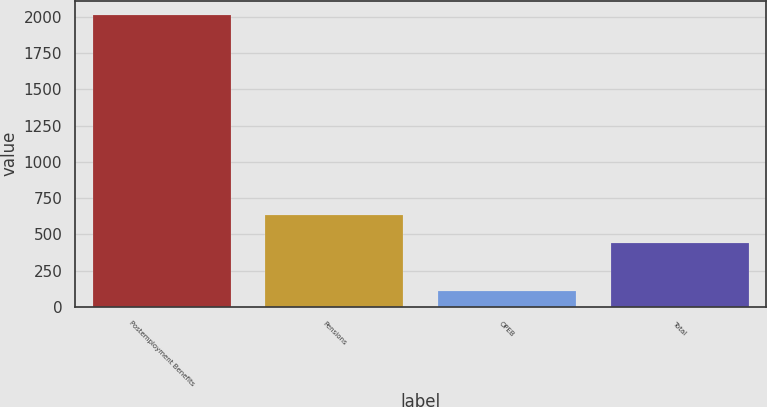Convert chart to OTSL. <chart><loc_0><loc_0><loc_500><loc_500><bar_chart><fcel>Postemployment Benefits<fcel>Pensions<fcel>OPEB<fcel>Total<nl><fcel>2011<fcel>632.9<fcel>112<fcel>443<nl></chart> 